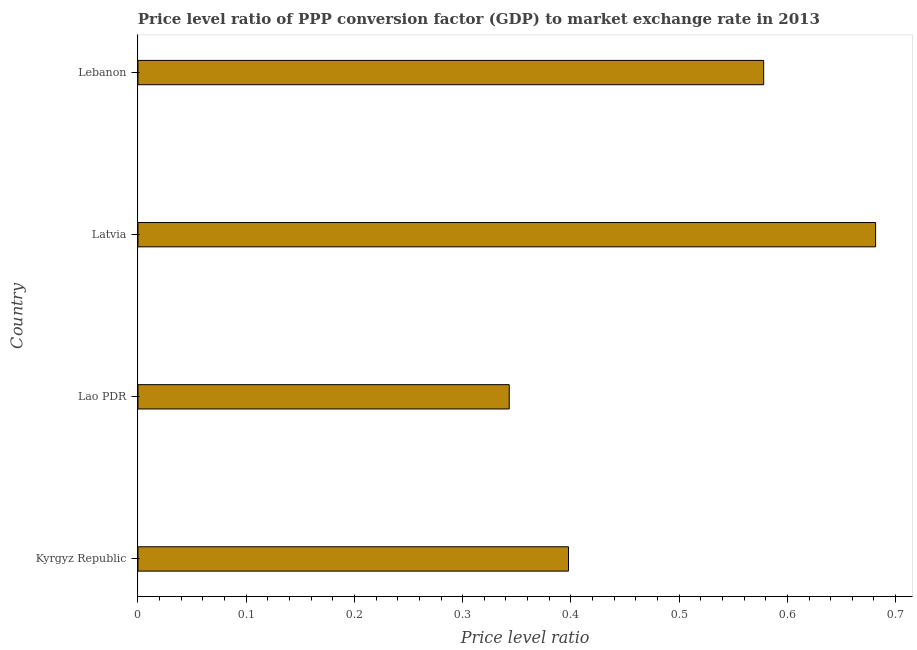Does the graph contain any zero values?
Offer a terse response. No. What is the title of the graph?
Give a very brief answer. Price level ratio of PPP conversion factor (GDP) to market exchange rate in 2013. What is the label or title of the X-axis?
Offer a very short reply. Price level ratio. What is the label or title of the Y-axis?
Ensure brevity in your answer.  Country. What is the price level ratio in Lao PDR?
Offer a very short reply. 0.34. Across all countries, what is the maximum price level ratio?
Give a very brief answer. 0.68. Across all countries, what is the minimum price level ratio?
Your answer should be compact. 0.34. In which country was the price level ratio maximum?
Provide a short and direct response. Latvia. In which country was the price level ratio minimum?
Give a very brief answer. Lao PDR. What is the sum of the price level ratio?
Give a very brief answer. 2. What is the difference between the price level ratio in Kyrgyz Republic and Latvia?
Ensure brevity in your answer.  -0.28. What is the median price level ratio?
Provide a short and direct response. 0.49. What is the ratio of the price level ratio in Kyrgyz Republic to that in Lao PDR?
Provide a short and direct response. 1.16. Is the difference between the price level ratio in Kyrgyz Republic and Lebanon greater than the difference between any two countries?
Your response must be concise. No. What is the difference between the highest and the second highest price level ratio?
Ensure brevity in your answer.  0.1. Is the sum of the price level ratio in Kyrgyz Republic and Lebanon greater than the maximum price level ratio across all countries?
Make the answer very short. Yes. What is the difference between the highest and the lowest price level ratio?
Offer a terse response. 0.34. In how many countries, is the price level ratio greater than the average price level ratio taken over all countries?
Offer a terse response. 2. Are all the bars in the graph horizontal?
Keep it short and to the point. Yes. How many countries are there in the graph?
Give a very brief answer. 4. What is the difference between two consecutive major ticks on the X-axis?
Your response must be concise. 0.1. What is the Price level ratio in Kyrgyz Republic?
Offer a very short reply. 0.4. What is the Price level ratio of Lao PDR?
Your answer should be compact. 0.34. What is the Price level ratio of Latvia?
Ensure brevity in your answer.  0.68. What is the Price level ratio in Lebanon?
Offer a terse response. 0.58. What is the difference between the Price level ratio in Kyrgyz Republic and Lao PDR?
Your answer should be compact. 0.05. What is the difference between the Price level ratio in Kyrgyz Republic and Latvia?
Keep it short and to the point. -0.28. What is the difference between the Price level ratio in Kyrgyz Republic and Lebanon?
Your answer should be very brief. -0.18. What is the difference between the Price level ratio in Lao PDR and Latvia?
Give a very brief answer. -0.34. What is the difference between the Price level ratio in Lao PDR and Lebanon?
Offer a terse response. -0.24. What is the difference between the Price level ratio in Latvia and Lebanon?
Provide a succinct answer. 0.1. What is the ratio of the Price level ratio in Kyrgyz Republic to that in Lao PDR?
Your answer should be compact. 1.16. What is the ratio of the Price level ratio in Kyrgyz Republic to that in Latvia?
Offer a very short reply. 0.58. What is the ratio of the Price level ratio in Kyrgyz Republic to that in Lebanon?
Your response must be concise. 0.69. What is the ratio of the Price level ratio in Lao PDR to that in Latvia?
Keep it short and to the point. 0.5. What is the ratio of the Price level ratio in Lao PDR to that in Lebanon?
Make the answer very short. 0.59. What is the ratio of the Price level ratio in Latvia to that in Lebanon?
Offer a terse response. 1.18. 